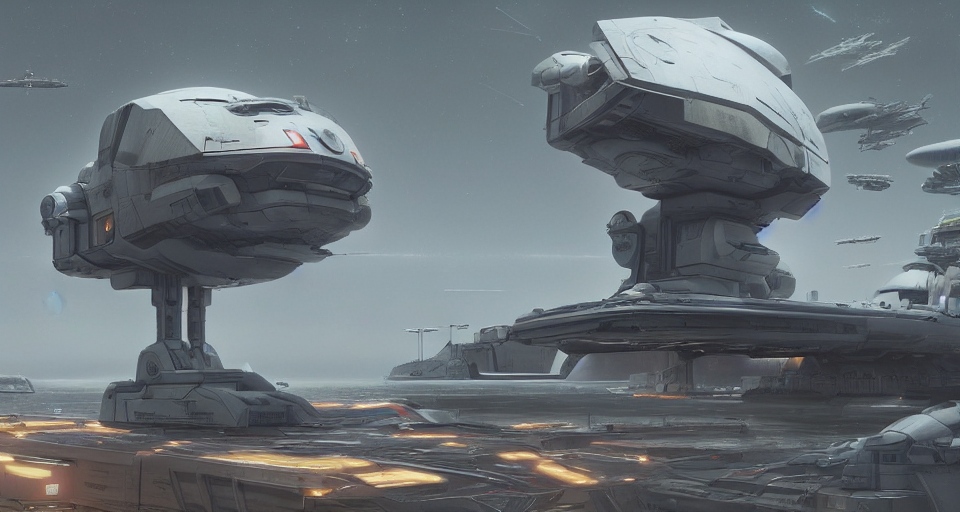Is the image blurry? The image is clear and sharp, displaying a detailed science fiction scene with impressive quality. 